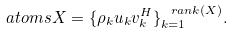Convert formula to latex. <formula><loc_0><loc_0><loc_500><loc_500>\ a t o m s { X } = \{ \rho _ { k } u _ { k } v _ { k } ^ { H } \} _ { k = 1 } ^ { \ r a n k ( X ) } .</formula> 